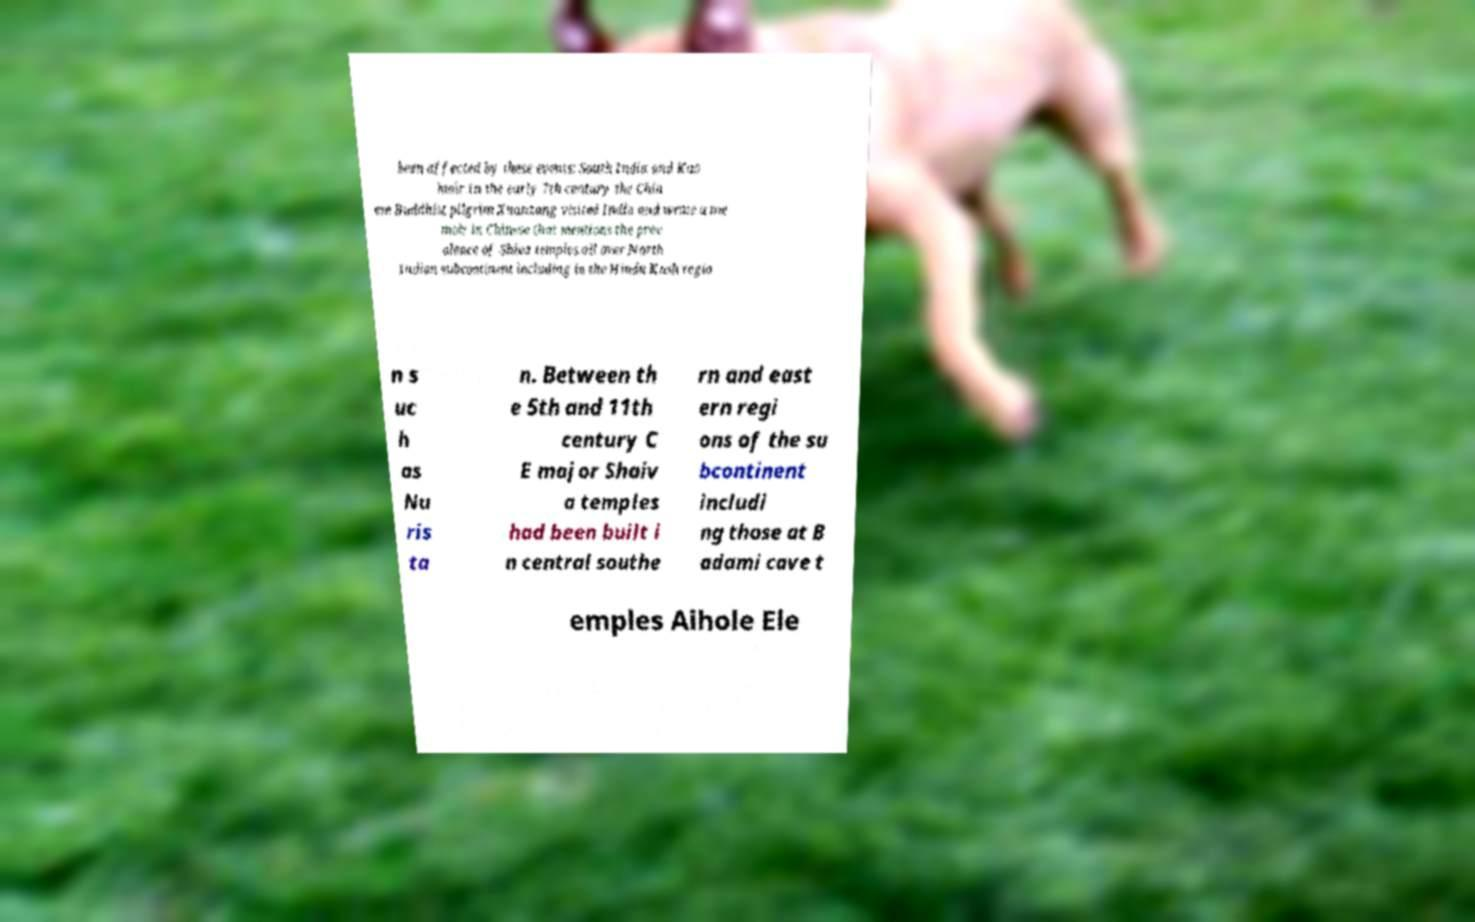Can you accurately transcribe the text from the provided image for me? been affected by these events: South India and Kas hmir.In the early 7th century the Chin ese Buddhist pilgrim Xuanzang visited India and wrote a me moir in Chinese that mentions the prev alence of Shiva temples all over North Indian subcontinent including in the Hindu Kush regio n s uc h as Nu ris ta n. Between th e 5th and 11th century C E major Shaiv a temples had been built i n central southe rn and east ern regi ons of the su bcontinent includi ng those at B adami cave t emples Aihole Ele 